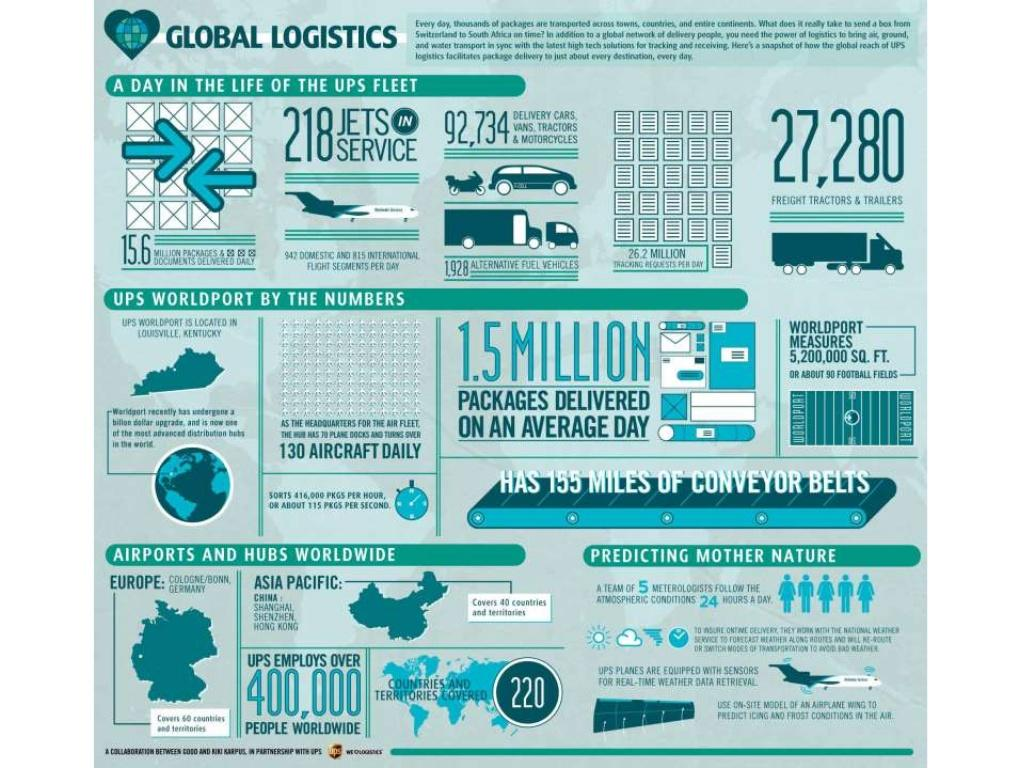Outline some significant characteristics in this image. UPS has a total of 27,280 freight tractors and trailers available in its logistics company. UPSIgnited Logistics has coverage in 220 countries and territories worldwide, providing efficient and reliable shipping services to customers worldwide. According to available data, the total number of people employed by UPS logistics company around the world exceeds 400,000. Approximately 1.5 million packets are delivered by the UPS on an average day. 